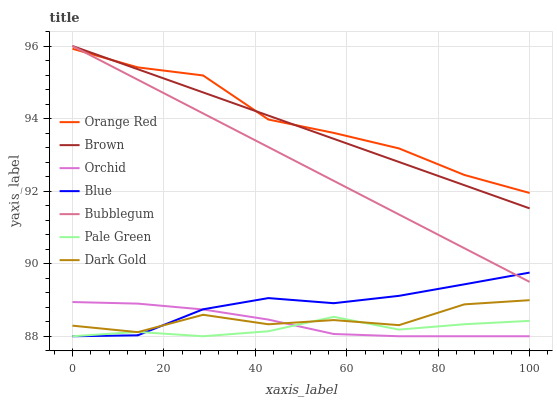Does Pale Green have the minimum area under the curve?
Answer yes or no. Yes. Does Orange Red have the maximum area under the curve?
Answer yes or no. Yes. Does Brown have the minimum area under the curve?
Answer yes or no. No. Does Brown have the maximum area under the curve?
Answer yes or no. No. Is Brown the smoothest?
Answer yes or no. Yes. Is Dark Gold the roughest?
Answer yes or no. Yes. Is Dark Gold the smoothest?
Answer yes or no. No. Is Brown the roughest?
Answer yes or no. No. Does Brown have the lowest value?
Answer yes or no. No. Does Bubblegum have the highest value?
Answer yes or no. Yes. Does Dark Gold have the highest value?
Answer yes or no. No. Is Dark Gold less than Orange Red?
Answer yes or no. Yes. Is Orange Red greater than Orchid?
Answer yes or no. Yes. Does Dark Gold intersect Orange Red?
Answer yes or no. No. 